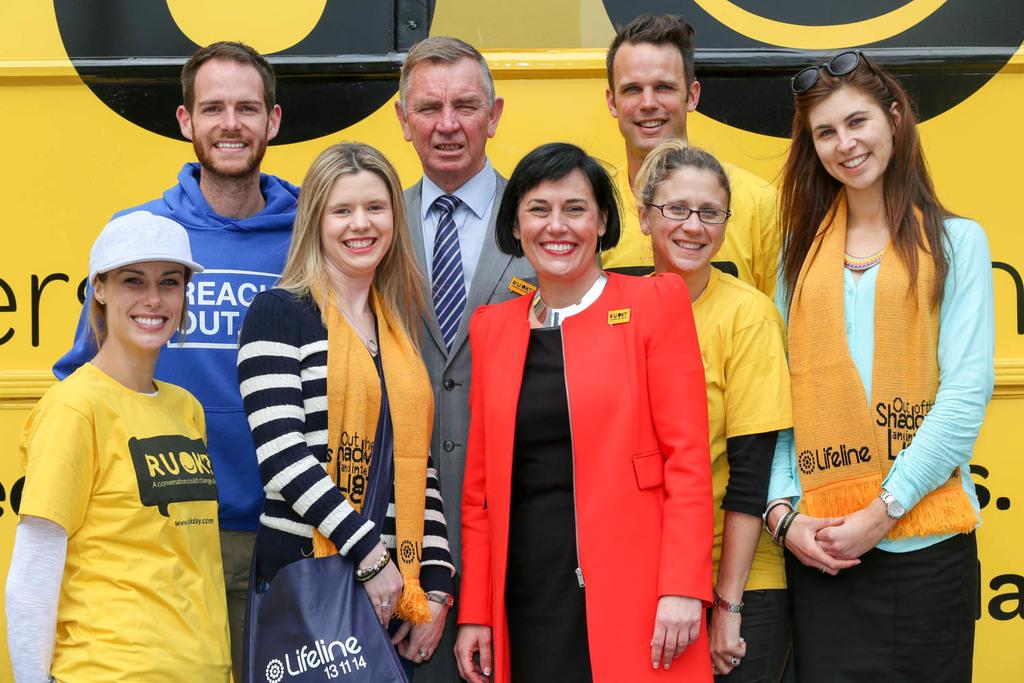What is the word written on the blue bag?
Give a very brief answer. Lifeline. 